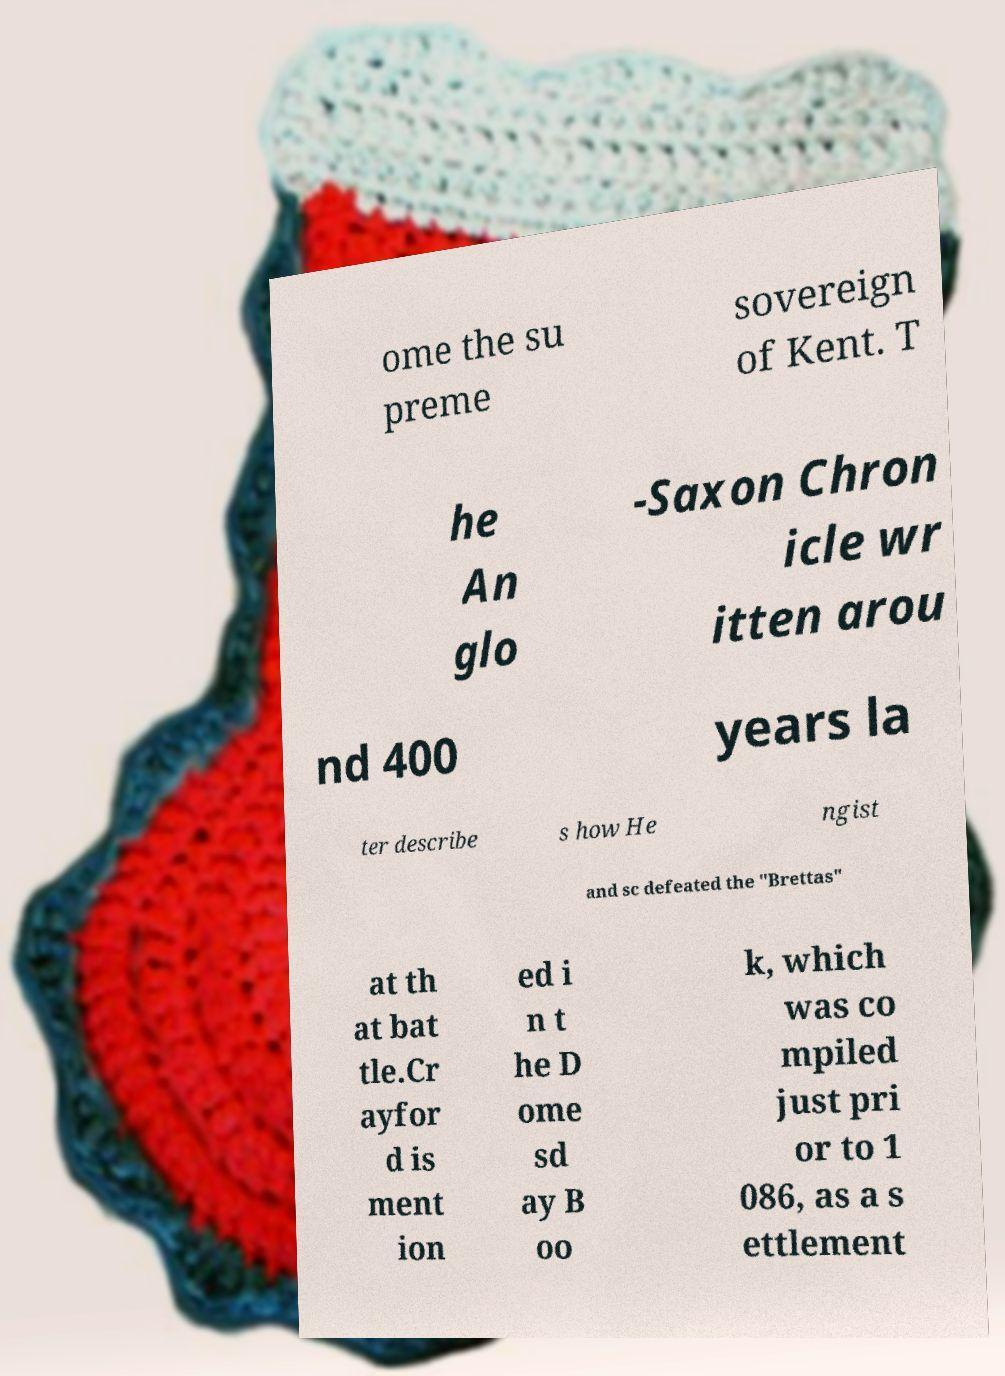Please identify and transcribe the text found in this image. ome the su preme sovereign of Kent. T he An glo -Saxon Chron icle wr itten arou nd 400 years la ter describe s how He ngist and sc defeated the "Brettas" at th at bat tle.Cr ayfor d is ment ion ed i n t he D ome sd ay B oo k, which was co mpiled just pri or to 1 086, as a s ettlement 